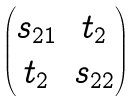Convert formula to latex. <formula><loc_0><loc_0><loc_500><loc_500>\begin{pmatrix} s _ { 2 1 } & t _ { 2 } \\ t _ { 2 } & s _ { 2 2 } \end{pmatrix}</formula> 